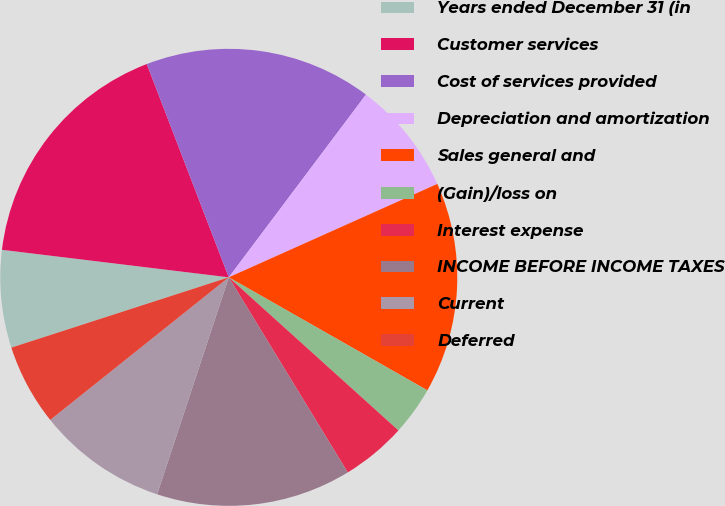Convert chart to OTSL. <chart><loc_0><loc_0><loc_500><loc_500><pie_chart><fcel>Years ended December 31 (in<fcel>Customer services<fcel>Cost of services provided<fcel>Depreciation and amortization<fcel>Sales general and<fcel>(Gain)/loss on<fcel>Interest expense<fcel>INCOME BEFORE INCOME TAXES<fcel>Current<fcel>Deferred<nl><fcel>6.9%<fcel>17.24%<fcel>16.09%<fcel>8.05%<fcel>14.94%<fcel>3.45%<fcel>4.6%<fcel>13.79%<fcel>9.2%<fcel>5.75%<nl></chart> 